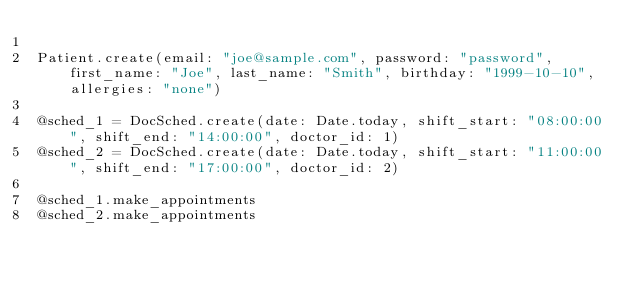Convert code to text. <code><loc_0><loc_0><loc_500><loc_500><_Ruby_>
Patient.create(email: "joe@sample.com", password: "password", first_name: "Joe", last_name: "Smith", birthday: "1999-10-10", allergies: "none")

@sched_1 = DocSched.create(date: Date.today, shift_start: "08:00:00", shift_end: "14:00:00", doctor_id: 1)
@sched_2 = DocSched.create(date: Date.today, shift_start: "11:00:00", shift_end: "17:00:00", doctor_id: 2)

@sched_1.make_appointments
@sched_2.make_appointments
</code> 